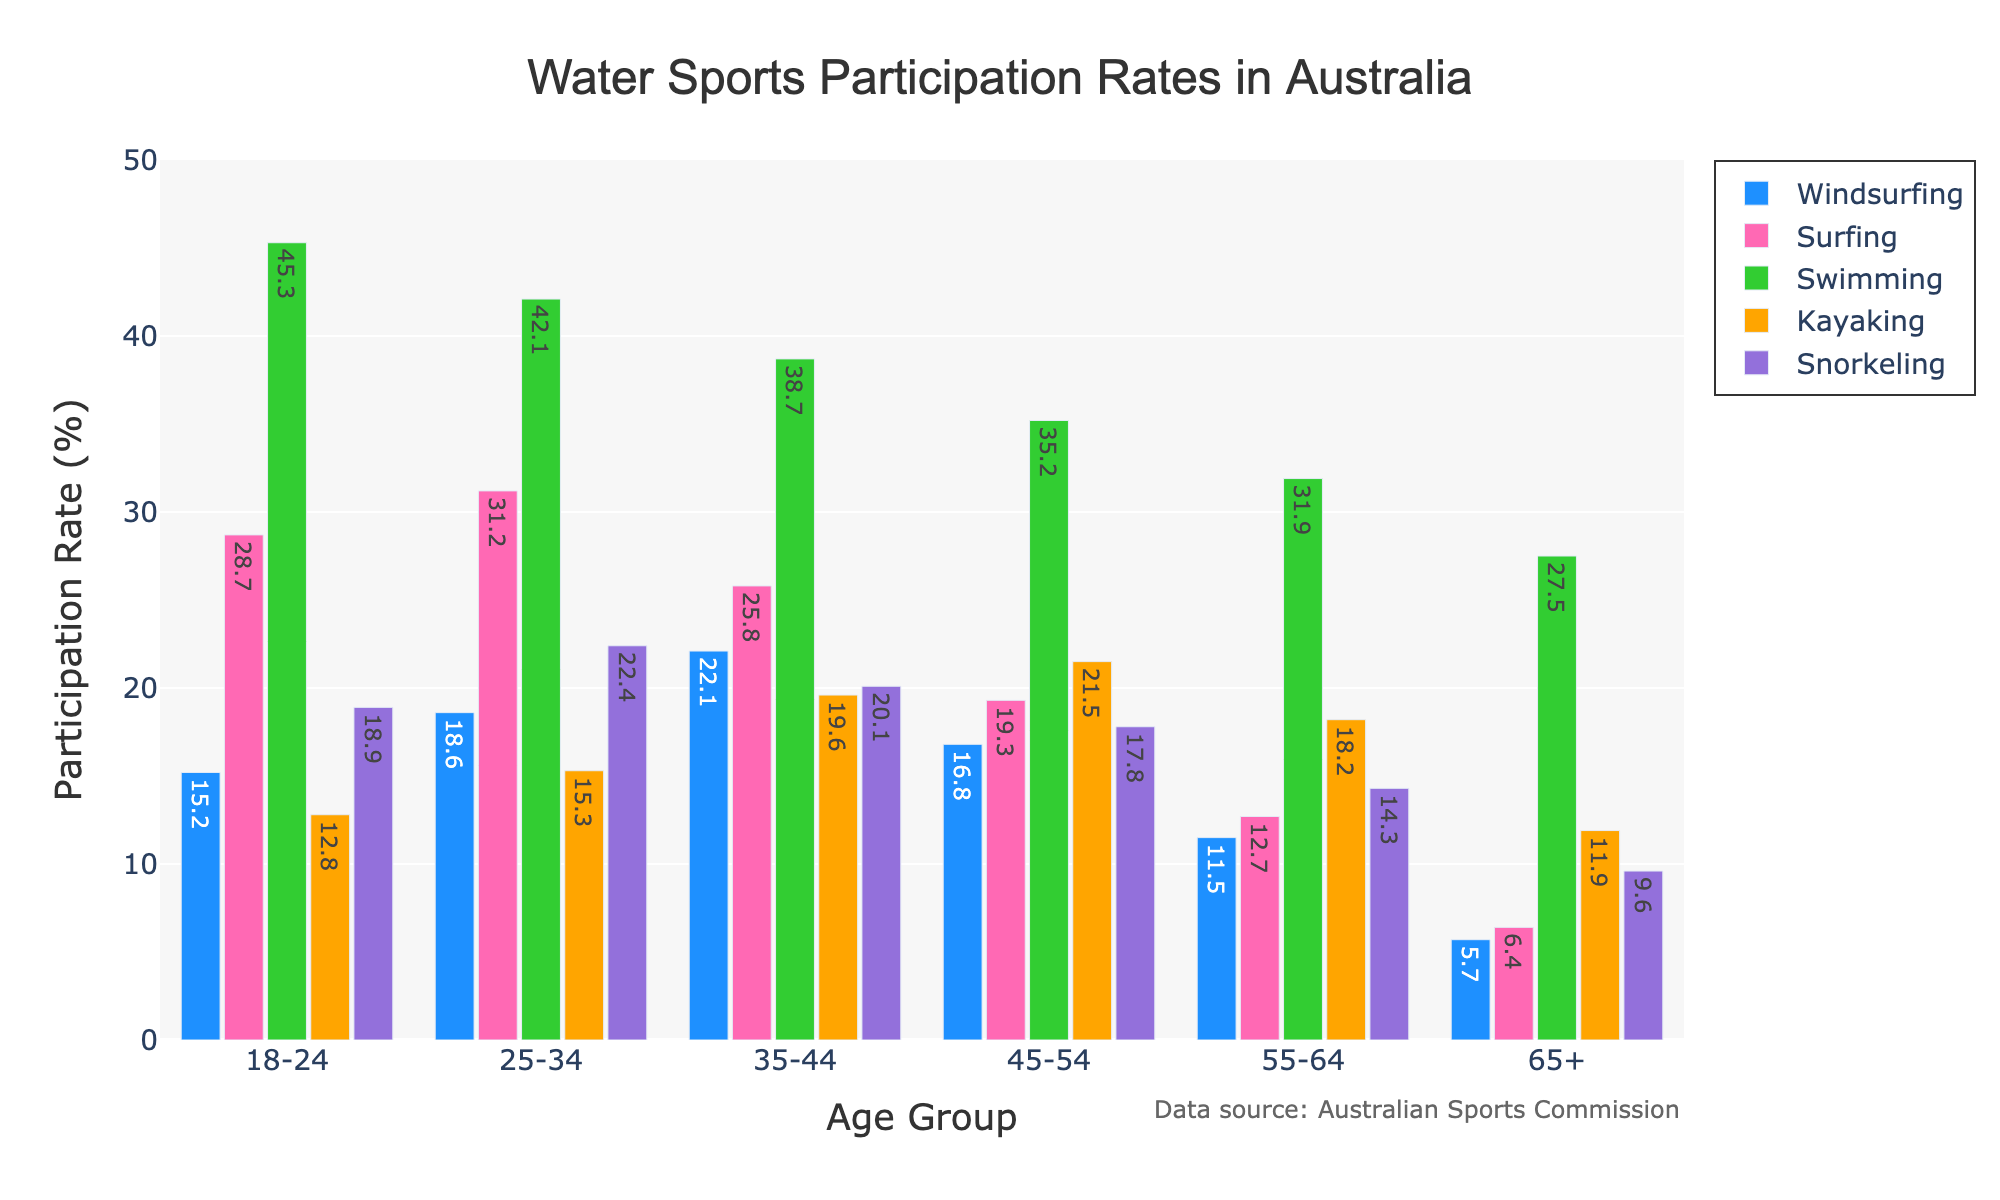What age group has the highest participation rate in windsurfing? The figure shows the participation rates for windsurfing across different age groups. By examining the heights of the bars for windsurfing, the highest bar corresponds to the 35-44 age group with a participation rate of 22.1%.
Answer: 35-44 age group How does the participation rate in swimming for the 18-24 age group compare to the 65+ age group? To find the comparison, look at the bars representing swimming for the 18-24 and 65+ age groups. The participation rate for 18-24 age group is 45.3%, whereas for the 65+ age group it is 27.5%. The 18-24 age group has a higher participation rate.
Answer: 18-24 age group What's the sum of participation rates in kayaking for the 25-34 and 35-44 age groups? Check the bars representing kayaking participation for the 25-34 and 35-44 age groups, which are 15.3% and 19.6% respectively. Summing them up gives 15.3 + 19.6 = 34.9%.
Answer: 34.9% Which activity has the lowest participation rate in the 55-64 age group? Find the bars representing the activities in the 55-64 age group and identify the lowest bar. Snorkeling has the lowest participation rate at 14.3%.
Answer: Snorkeling What is the average participation rate in windsurfing across all age groups? Look at the participation rates for windsurfing in all age groups: 15.2%, 18.6%, 22.1%, 16.8%, 11.5%, 5.7%. The average can be calculated as (15.2 + 18.6 + 22.1 + 16.8 + 11.5 + 5.7) / 6 = 15%.
Answer: 15% Compare the participation rates in surfing for the 25-34 age group and kayaking for the 45-54 age group. Which is higher? The participation rate in surfing for the 25-34 age group is 31.2%, and for kayaking in the 45-54 age group, it is 21.5%. Surfing has a higher participation rate.
Answer: Surfing What is the difference in participation rates in snorkeling between the 18-24 and 65+ age groups? Check the snorkeling participation rates for the 18-24 and 65+ age groups, which are 18.9% and 9.6% respectively. The difference is calculated as 18.9 - 9.6 = 9.3%.
Answer: 9.3% Which activity shows a decline in participation rate as the age group increases from 18-24 to 65+? By examining the figure, it is noticeable that for windsurfing (15.2% to 5.7%), surfing (28.7% to 6.4%), swimming (45.3% to 27.5%), kayaking (12.8% to 11.9%), and snorkeling (18.9% to 9.6%), all activity participation rates drop as age increases.
Answer: All activities What is the participation rate for the most popular water sport in the 35-44 age group? The most popular water sport in the 35-44 age group is identified by the tallest bar in that group, which is swimming with a participation rate of 38.7%.
Answer: 38.7% How much higher is the participation rate in surfing for the 18-24 age group compared to the 45-54 age group? The participation rate in surfing is 28.7% for the 18-24 age group and 19.3% for the 45-54 age group. The difference is 28.7 - 19.3 = 9.4%.
Answer: 9.4% 